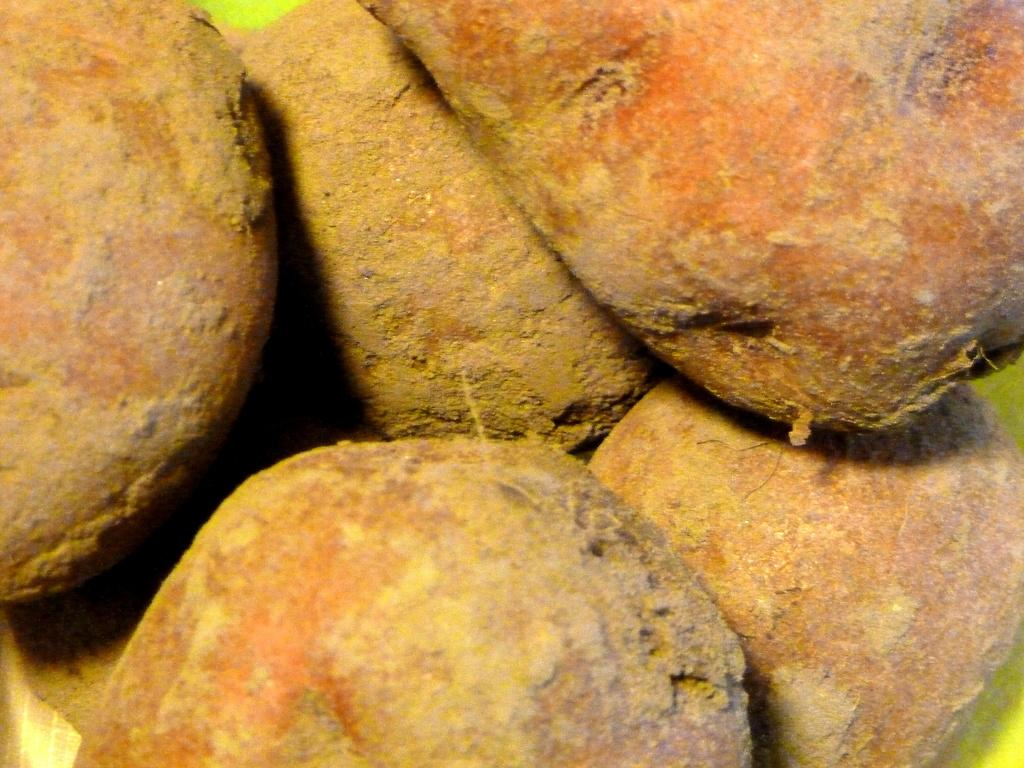What type of natural elements can be seen in the image? There are rocks in the image. Can you describe the texture or appearance of the rocks? The texture or appearance of the rocks cannot be determined from the image alone. Are there any other natural elements visible in the image besides the rocks? The provided facts do not mention any other natural elements in the image. Can you tell me how deep the quicksand is in the image? There is no quicksand present in the image; it only features rocks. 